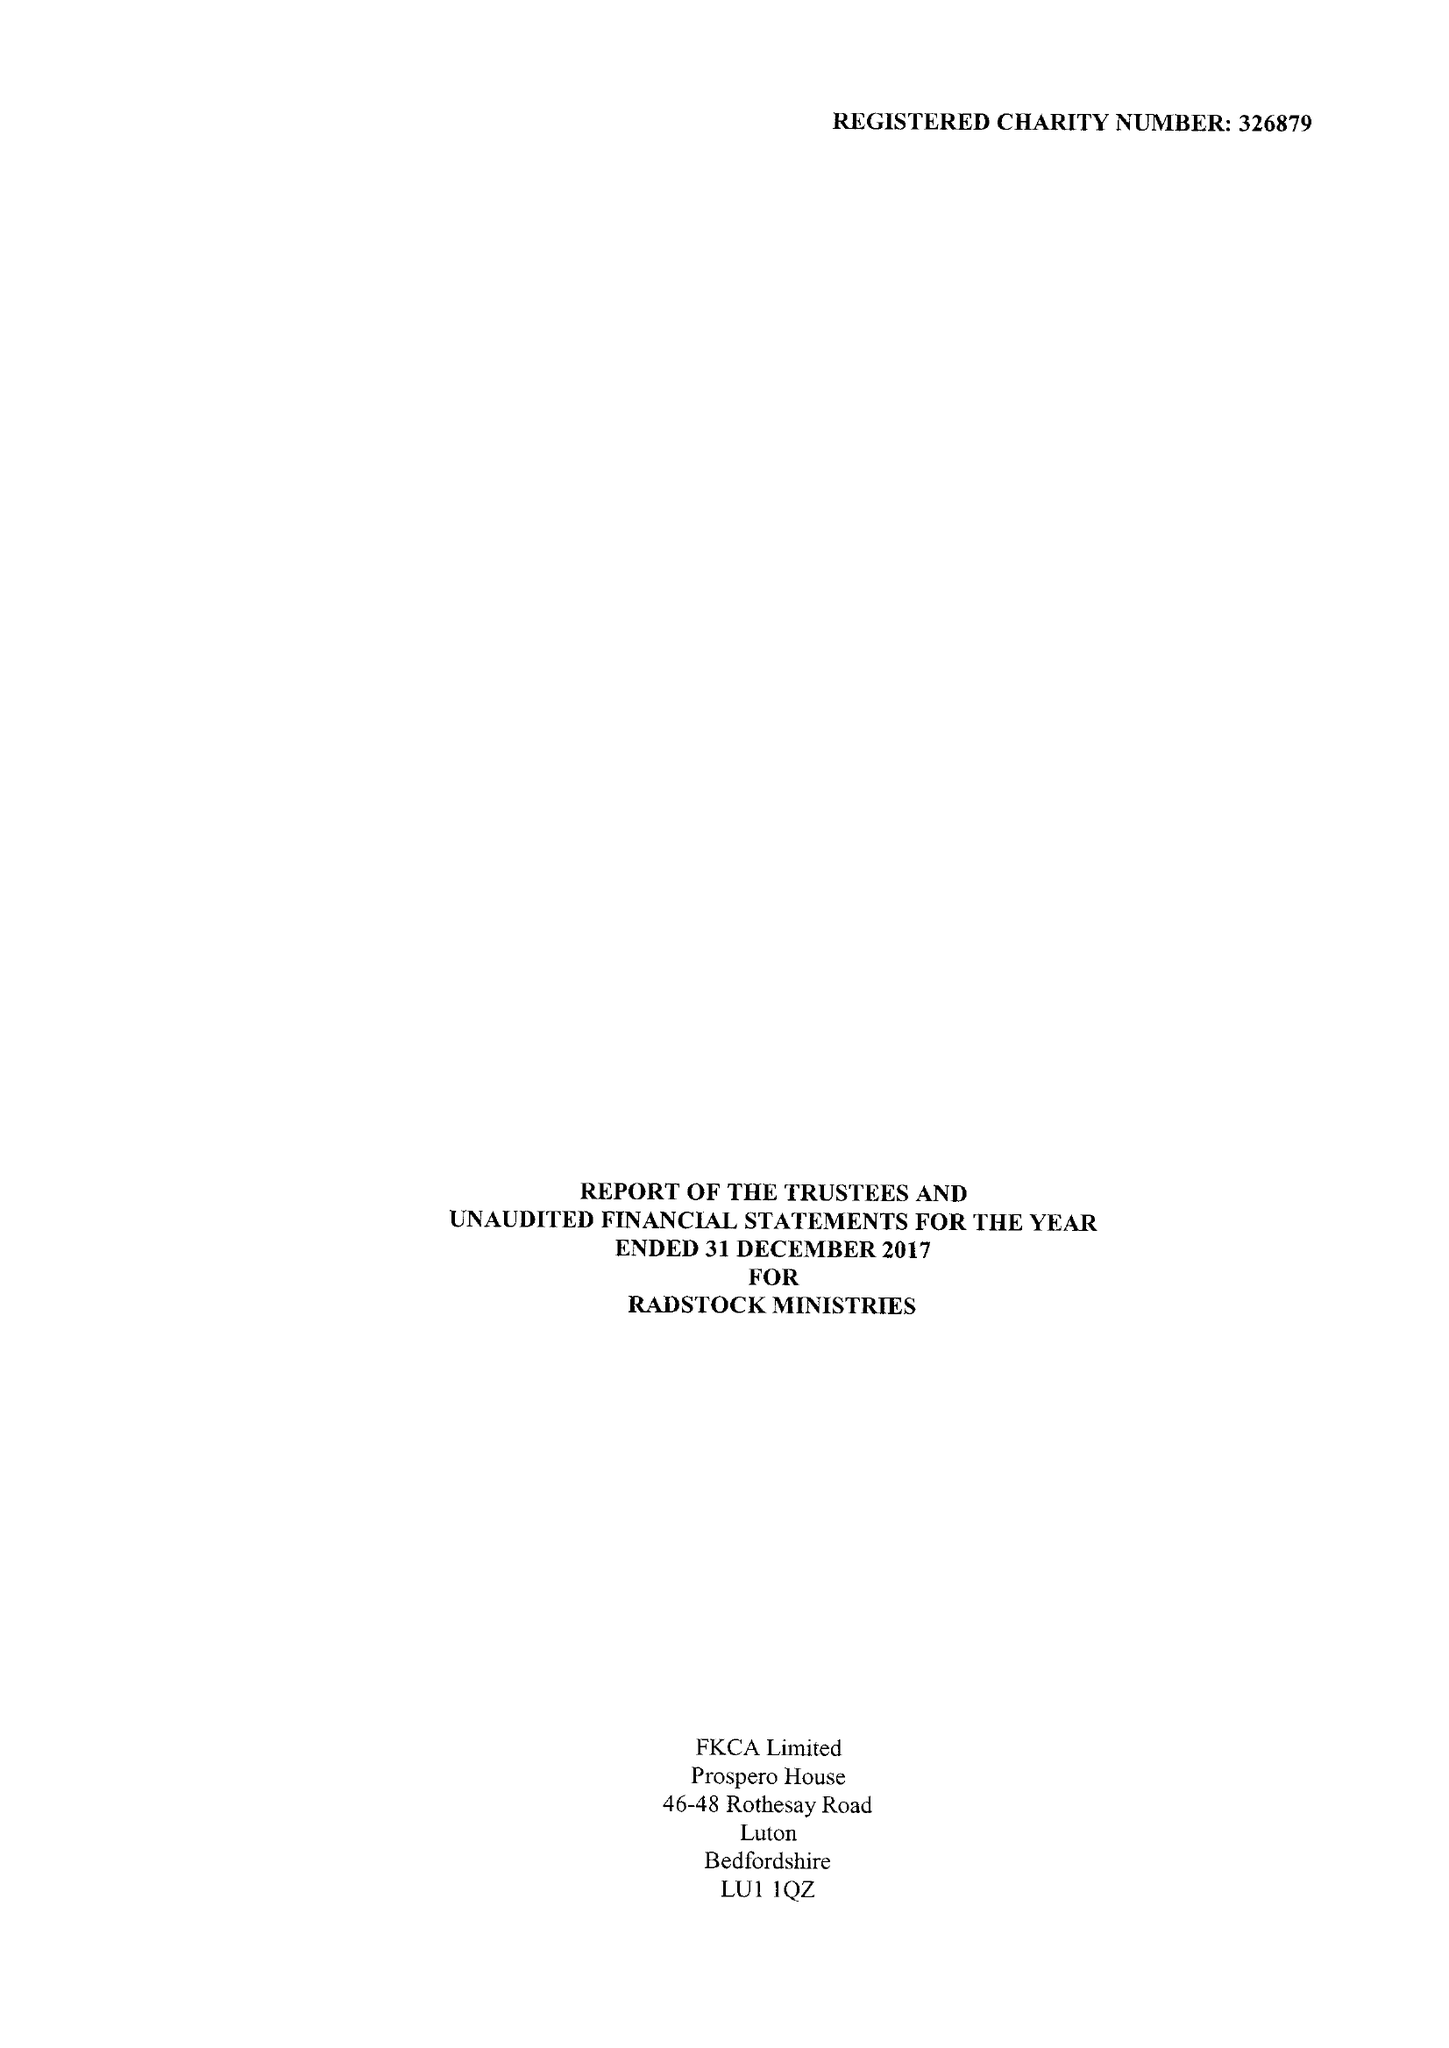What is the value for the spending_annually_in_british_pounds?
Answer the question using a single word or phrase. 197356.00 